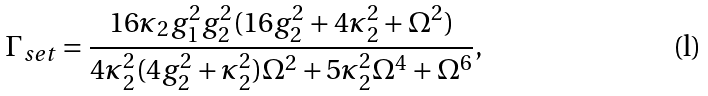Convert formula to latex. <formula><loc_0><loc_0><loc_500><loc_500>\Gamma _ { s e t } = \frac { 1 6 \kappa _ { 2 } g _ { 1 } ^ { 2 } g _ { 2 } ^ { 2 } ( 1 6 g _ { 2 } ^ { 2 } + 4 \kappa _ { 2 } ^ { 2 } + \Omega ^ { 2 } ) } { 4 \kappa _ { 2 } ^ { 2 } ( 4 g _ { 2 } ^ { 2 } + \kappa _ { 2 } ^ { 2 } ) \Omega ^ { 2 } + 5 \kappa _ { 2 } ^ { 2 } \Omega ^ { 4 } + \Omega ^ { 6 } } ,</formula> 